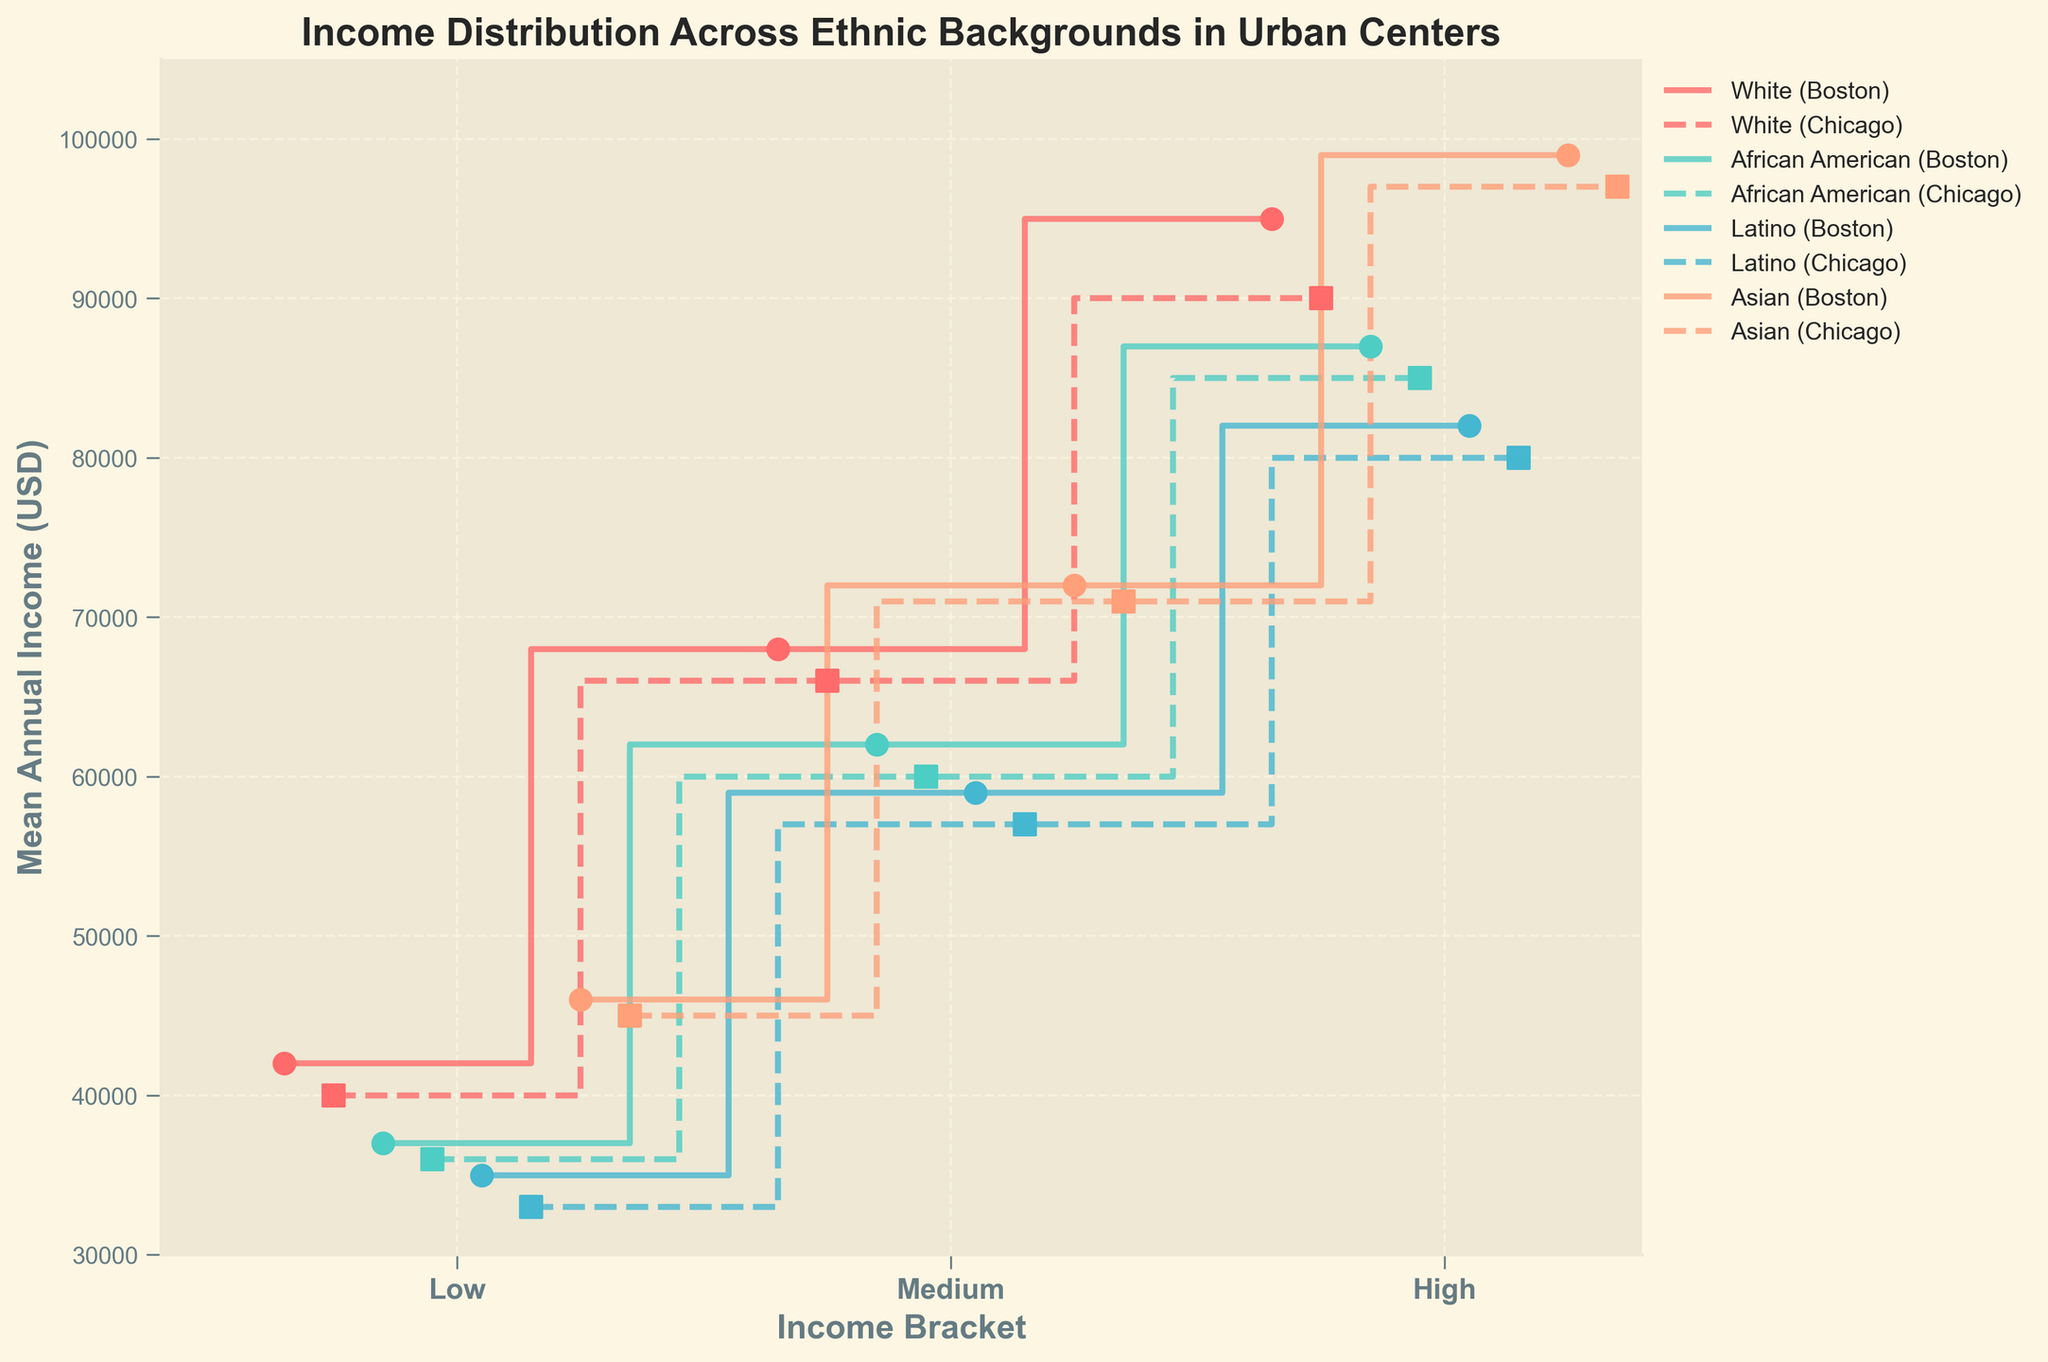What is the title of the plot? The title is typically located at the top of the figure and provides an overview of what the plot is about. Here, it states "Income Distribution Across Ethnic Backgrounds in Urban Centers".
Answer: Income Distribution Across Ethnic Backgrounds in Urban Centers What does each step represent in the plot? In a stair plot, each step typically represents the value of the mean annual income within a specific income bracket (Low, Medium, High) for a particular ethnic group in a given urban center. Porting one ethnic group, each line and step highlight the different income levels in Boston and Chicago.
Answer: Mean annual income within income brackets for each ethnic group in Boston and Chicago Which ethnic group has the highest mean annual income in Boston in the High-income bracket? To find this information, look at the step heights representing the High-income bracket in Boston. The highest step among all ethnic groups represents the highest mean income. For Boston High-income, Asians have the highest mean annual income at $99,000.
Answer: Asian How does the income for Latinos in the Medium bracket compare between Boston and Chicago? Look at the steps corresponding to Latinos in the Medium income bracket for both Boston and Chicago. Compare their heights. In Boston, Latinos have a mean annual income of $59,000 in the Medium bracket, while in Chicago, it is $57,000.
Answer: Boston is higher by $2,000 Which ethnic group has the smallest gap between Low and High-income brackets in Chicago? For each ethnic group in Chicago, subtract the Low-income mean annual income from the High-income mean annual income to find the income gap. The group with the smallest difference is African American with a gap of $49,000 ($85,000 - $36,000).
Answer: African American What is the average mean annual income for all ethnic groups in the High-income bracket in Boston? To find this, add the mean annual incomes for all ethnic groups in the Boston High-income bracket and divide by the number of groups (4). The values are $95,000, $87,000, $82,000, and $99,000. The sum is $363,000, and the average is $363,000 / 4 = $90,750.
Answer: $90,750 Which ethnic group shows the most consistent income levels (smallest range) across the three income brackets in Boston? Calculate the range (High - Low incomes) for each ethnic group in Boston. The smallest range will indicate the most consistent income levels. Asian has the smallest range in Boston (High $99,000 - Low $46,000 = $53,000).
Answer: Asian Does the overall trend for mean annual income in both Boston and Chicago show higher incomes for all ethnic groups as you move from Low to High-income brackets? Examine the steps representing the mean annual incomes for each ethnic group in ascending order of income brackets (Low to Medium to High). Each ethnic group should show an upward trend.
Answer: Yes Comparing the Medium-income bracket across all ethnic groups in Chicago, which ethnic group has the lowest mean annual income? Identify the steps corresponding to the Medium-income bracket for each ethnic group in Chicago and find the one with the lowest height. Latino has the lowest mean annual income in this bracket at $57,000.
Answer: Latino 